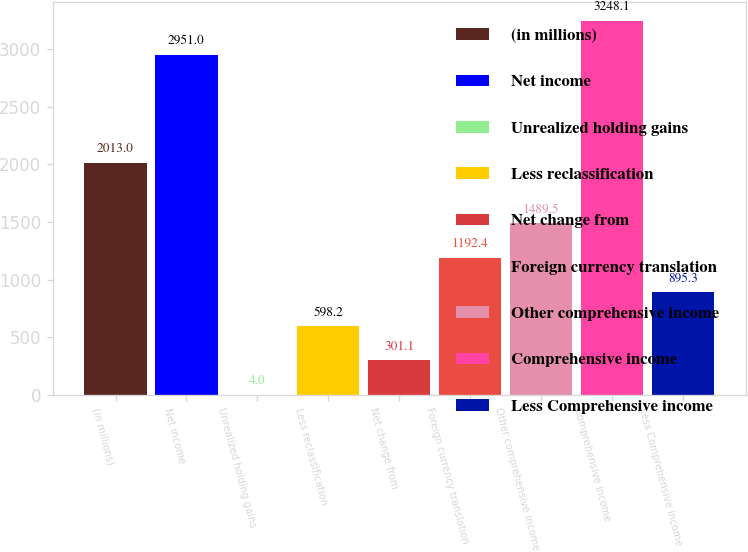<chart> <loc_0><loc_0><loc_500><loc_500><bar_chart><fcel>(in millions)<fcel>Net income<fcel>Unrealized holding gains<fcel>Less reclassification<fcel>Net change from<fcel>Foreign currency translation<fcel>Other comprehensive income<fcel>Comprehensive income<fcel>Less Comprehensive income<nl><fcel>2013<fcel>2951<fcel>4<fcel>598.2<fcel>301.1<fcel>1192.4<fcel>1489.5<fcel>3248.1<fcel>895.3<nl></chart> 